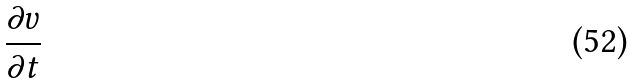Convert formula to latex. <formula><loc_0><loc_0><loc_500><loc_500>\frac { \partial v } { \partial t }</formula> 